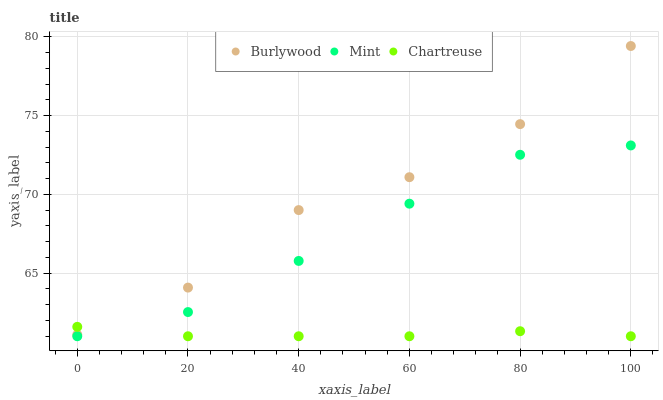Does Chartreuse have the minimum area under the curve?
Answer yes or no. Yes. Does Burlywood have the maximum area under the curve?
Answer yes or no. Yes. Does Mint have the minimum area under the curve?
Answer yes or no. No. Does Mint have the maximum area under the curve?
Answer yes or no. No. Is Chartreuse the smoothest?
Answer yes or no. Yes. Is Burlywood the roughest?
Answer yes or no. Yes. Is Mint the smoothest?
Answer yes or no. No. Is Mint the roughest?
Answer yes or no. No. Does Chartreuse have the lowest value?
Answer yes or no. Yes. Does Burlywood have the highest value?
Answer yes or no. Yes. Does Mint have the highest value?
Answer yes or no. No. Is Mint less than Burlywood?
Answer yes or no. Yes. Is Burlywood greater than Mint?
Answer yes or no. Yes. Does Mint intersect Chartreuse?
Answer yes or no. Yes. Is Mint less than Chartreuse?
Answer yes or no. No. Is Mint greater than Chartreuse?
Answer yes or no. No. Does Mint intersect Burlywood?
Answer yes or no. No. 